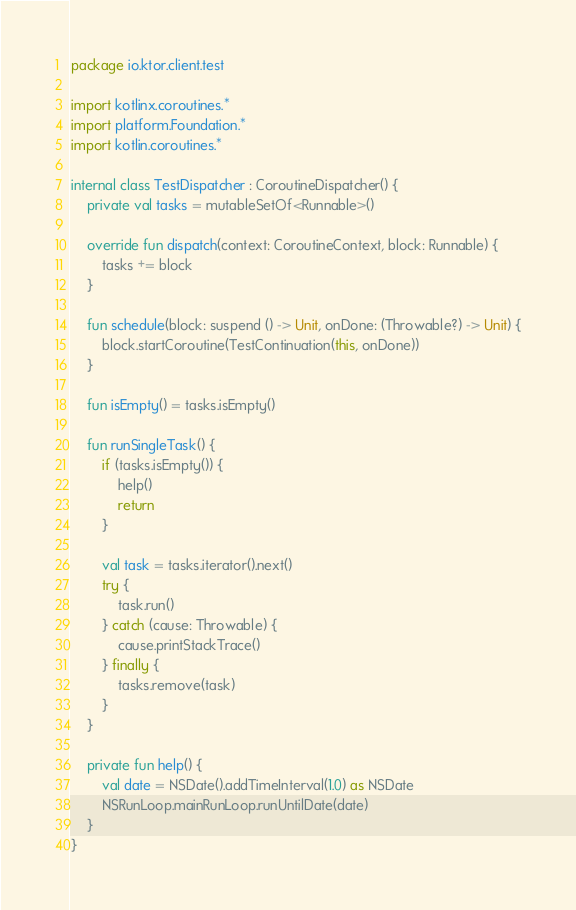Convert code to text. <code><loc_0><loc_0><loc_500><loc_500><_Kotlin_>package io.ktor.client.test

import kotlinx.coroutines.*
import platform.Foundation.*
import kotlin.coroutines.*

internal class TestDispatcher : CoroutineDispatcher() {
    private val tasks = mutableSetOf<Runnable>()

    override fun dispatch(context: CoroutineContext, block: Runnable) {
        tasks += block
    }

    fun schedule(block: suspend () -> Unit, onDone: (Throwable?) -> Unit) {
        block.startCoroutine(TestContinuation(this, onDone))
    }

    fun isEmpty() = tasks.isEmpty()

    fun runSingleTask() {
        if (tasks.isEmpty()) {
            help()
            return
        }

        val task = tasks.iterator().next()
        try {
            task.run()
        } catch (cause: Throwable) {
            cause.printStackTrace()
        } finally {
            tasks.remove(task)
        }
    }

    private fun help() {
        val date = NSDate().addTimeInterval(1.0) as NSDate
        NSRunLoop.mainRunLoop.runUntilDate(date)
    }
}
</code> 